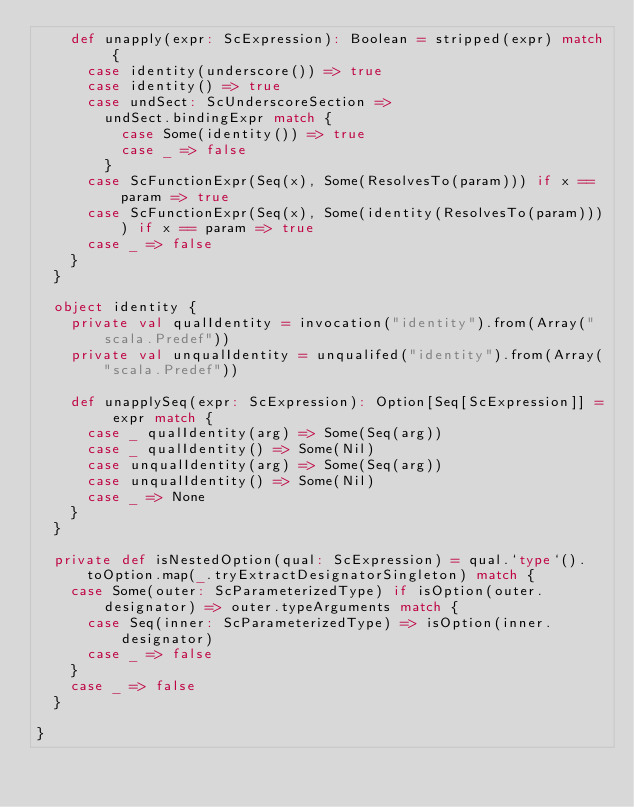<code> <loc_0><loc_0><loc_500><loc_500><_Scala_>    def unapply(expr: ScExpression): Boolean = stripped(expr) match {
      case identity(underscore()) => true
      case identity() => true
      case undSect: ScUnderscoreSection =>
        undSect.bindingExpr match {
          case Some(identity()) => true
          case _ => false
        }
      case ScFunctionExpr(Seq(x), Some(ResolvesTo(param))) if x == param => true
      case ScFunctionExpr(Seq(x), Some(identity(ResolvesTo(param)))) if x == param => true
      case _ => false
    }
  }

  object identity {
    private val qualIdentity = invocation("identity").from(Array("scala.Predef"))
    private val unqualIdentity = unqualifed("identity").from(Array("scala.Predef"))

    def unapplySeq(expr: ScExpression): Option[Seq[ScExpression]] = expr match {
      case _ qualIdentity(arg) => Some(Seq(arg))
      case _ qualIdentity() => Some(Nil)
      case unqualIdentity(arg) => Some(Seq(arg))
      case unqualIdentity() => Some(Nil)
      case _ => None
    }
  }

  private def isNestedOption(qual: ScExpression) = qual.`type`().toOption.map(_.tryExtractDesignatorSingleton) match {
    case Some(outer: ScParameterizedType) if isOption(outer.designator) => outer.typeArguments match {
      case Seq(inner: ScParameterizedType) => isOption(inner.designator)
      case _ => false
    }
    case _ => false
  }

}</code> 